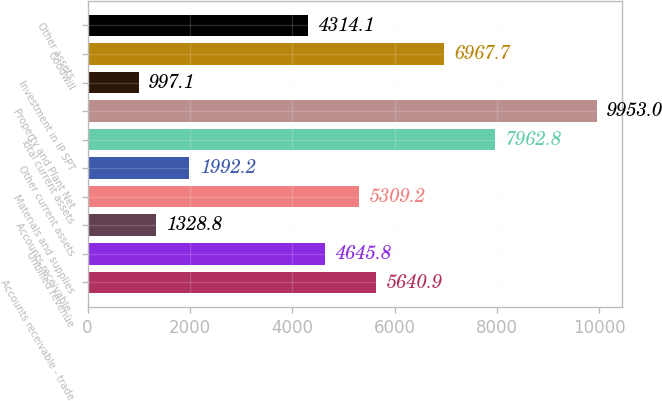Convert chart to OTSL. <chart><loc_0><loc_0><loc_500><loc_500><bar_chart><fcel>Accounts receivable - trade<fcel>Unbilled revenue<fcel>Accounts receivable -<fcel>Materials and supplies<fcel>Other current assets<fcel>Total current assets<fcel>Property and Plant Net<fcel>Investment in IP SPT<fcel>Goodwill<fcel>Other assets<nl><fcel>5640.9<fcel>4645.8<fcel>1328.8<fcel>5309.2<fcel>1992.2<fcel>7962.8<fcel>9953<fcel>997.1<fcel>6967.7<fcel>4314.1<nl></chart> 